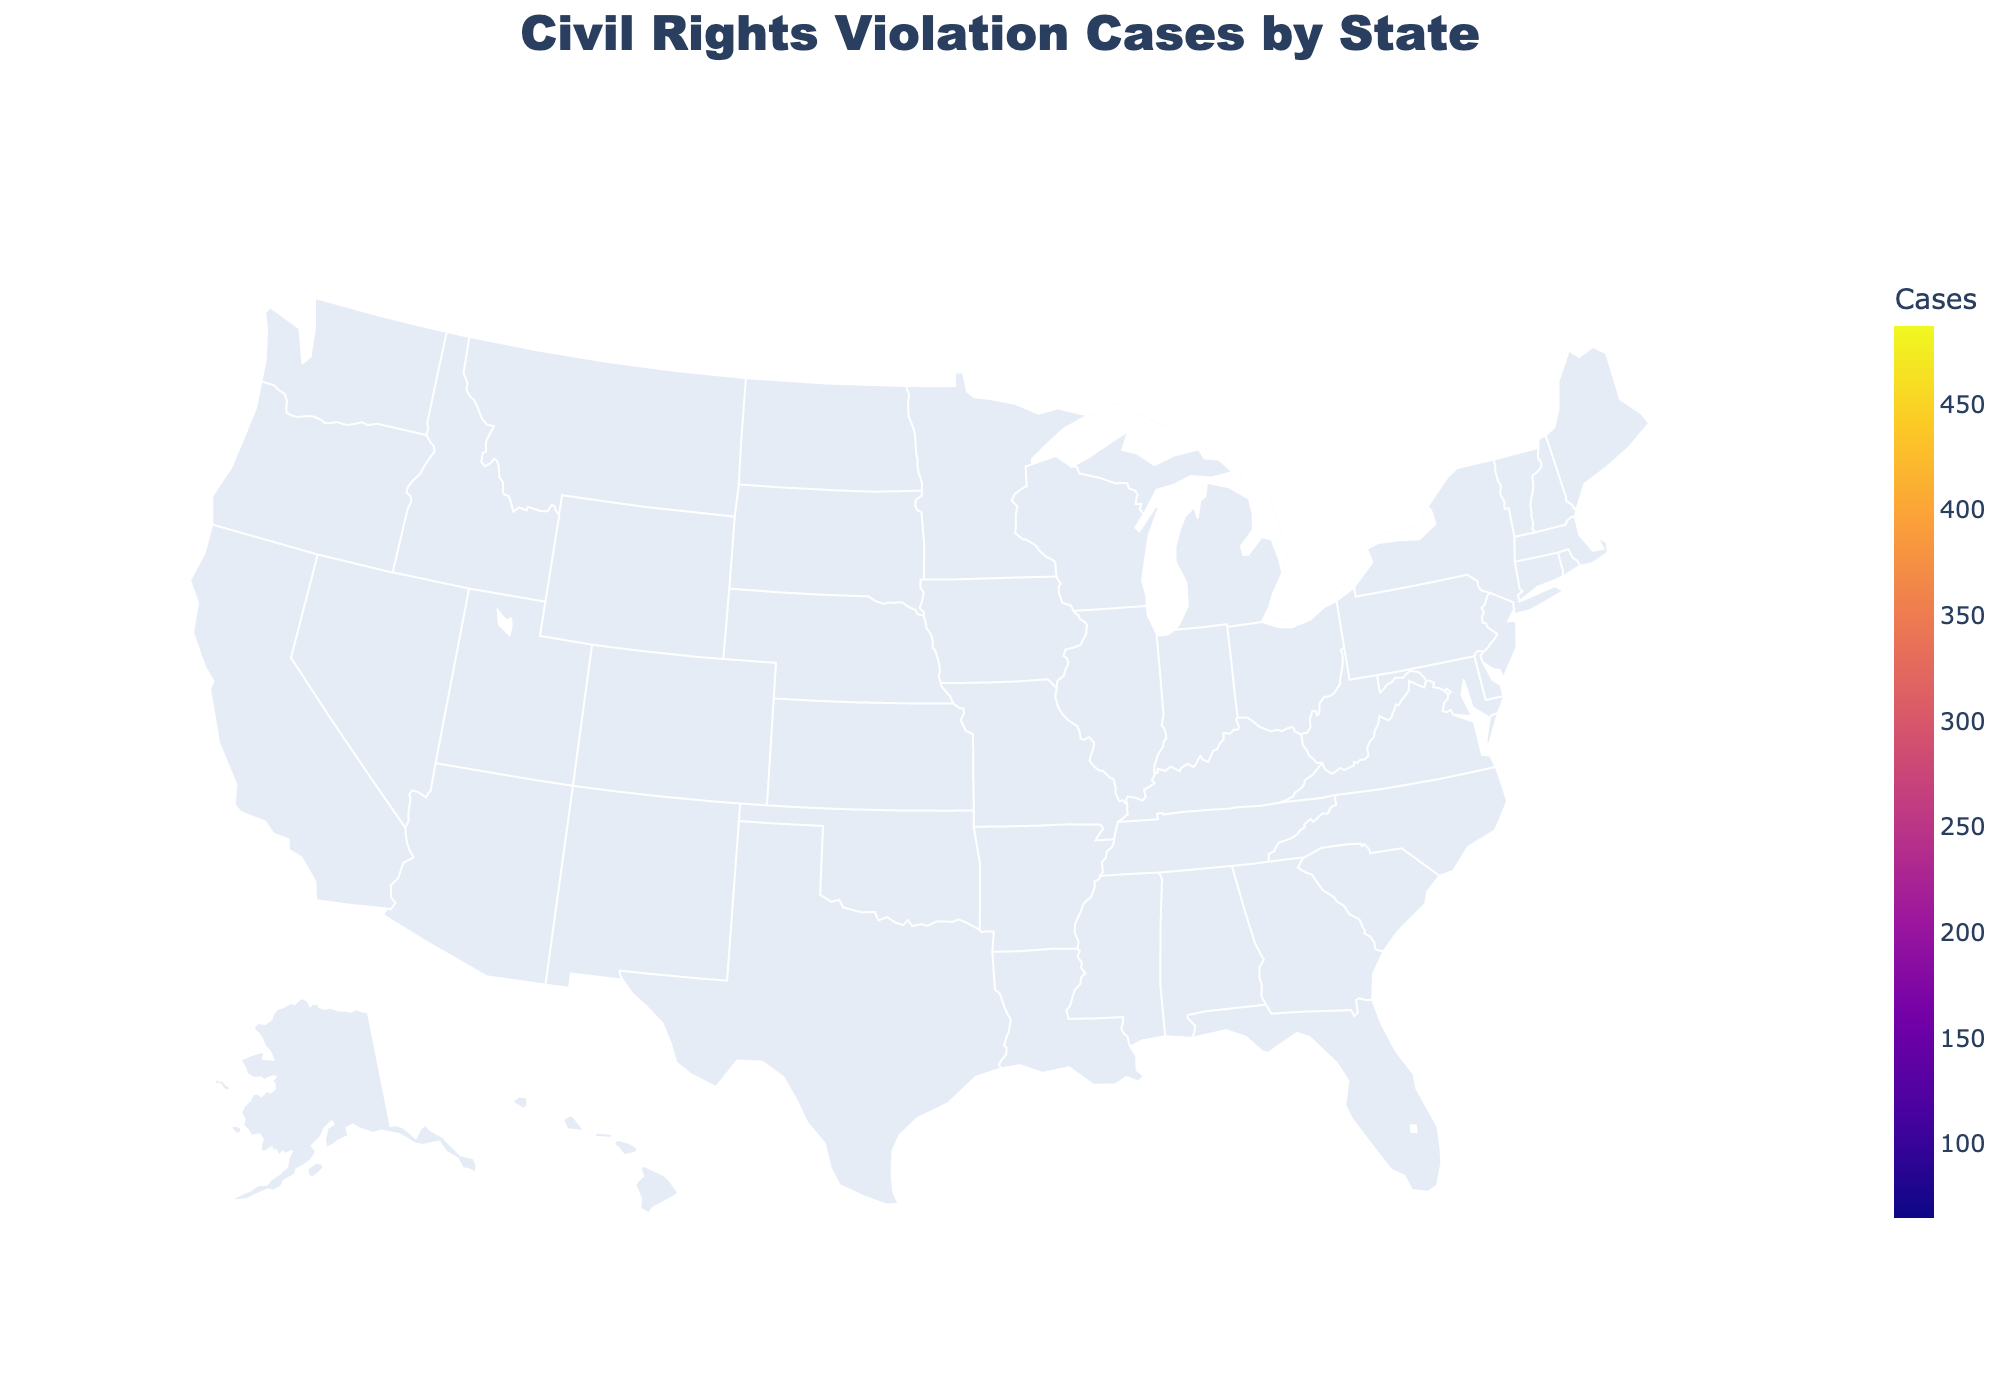What is the title of the figure? The title is usually found at the top center of the figure and summarizes what the plot is about. In this case, look at the top center of the plot.
Answer: Civil Rights Violation Cases by State Which state has the highest number of reported civil rights violation cases? This question requires identifying the state with the darkest color on the choropleth map, as it represents the highest number of cases. Look for the state shaded with the darkest color and check the value.
Answer: California How many reported civil rights violation cases are there in Texas? Hover over the state of Texas on the choropleth map to see the hover text with the number of reported cases.
Answer: 412 What is the median number of reported cases across all the states on the plot? To find the median, list all the values, find the middle value in this ordered list. Sorted values: 65, 68, 72, 79, 83, 91, 98, 105, 112, 124, 138, 152, 163, 176, 189, 245, 298, 356, 412, 487. The median is the average of the 10th and 11th values in this list. (124 + 138) / 2 = 262 / 2
Answer: 131 Which region has more cases, Illinois or Florida? Compare the values associated with Illinois and Florida on the map. Hover over both states to see their respective values and compare them.
Answer: Florida What is the total number of reported civil rights violation cases for the five states with the lowest numbers? Identify the five states with the smallest values and add them: Tennessee, Minnesota, Wisconsin, Maryland, Colorado. Add these values: 65 + 68 + 72 + 79 + 83 = 367
Answer: 367 Which states have more than 300 reported civil rights violation cases? Look for states with values greater than 300. Identify them by seeing the color scale or hovering over different states.
Answer: California, Texas, New York, Florida Are there any states in the plot with fewer than 100 reported violations? If so, name them. Look for states with values less than 100 and list them. This can be done by observing lighter shaded states and using hover text.
Answer: New Jersey, Arizona, Colorado, Maryland, Wisconsin, Minnesota, Tennessee What color scale is used in the map to represent the number of reported cases? Normally, the color scale is indicated in the legend; it can be inferred by observing the color gradient which progresses from one color to another. In this case, the color scale described is "Plasma".
Answer: Plasma 